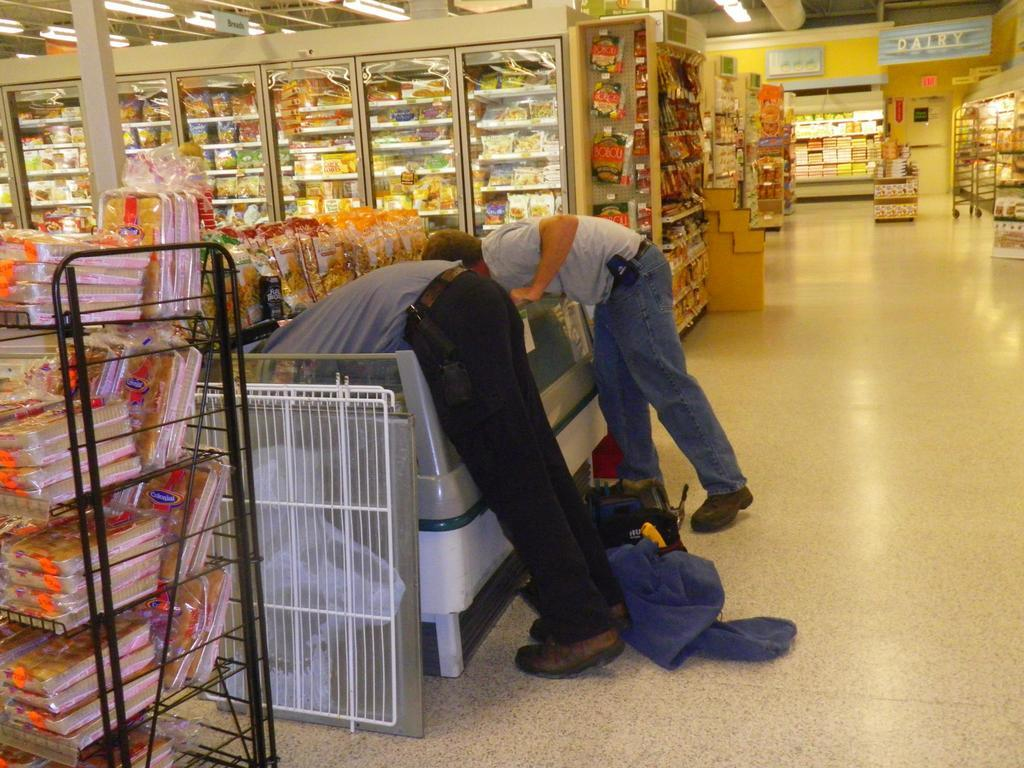How many people are present in the supermarket in the image? There are two people inside the supermarket in the image. What can be seen on the shelves and in trays in the supermarket? Items are arranged on shelves and in trays in the supermarket. What type of signage is present in the supermarket? There are boards in the supermarket. How is the supermarket illuminated? Lights are hanging from the roof in the supermarket. What type of toys can be seen on the shelves in the supermarket? There are no toys visible on the shelves in the supermarket in the image. 